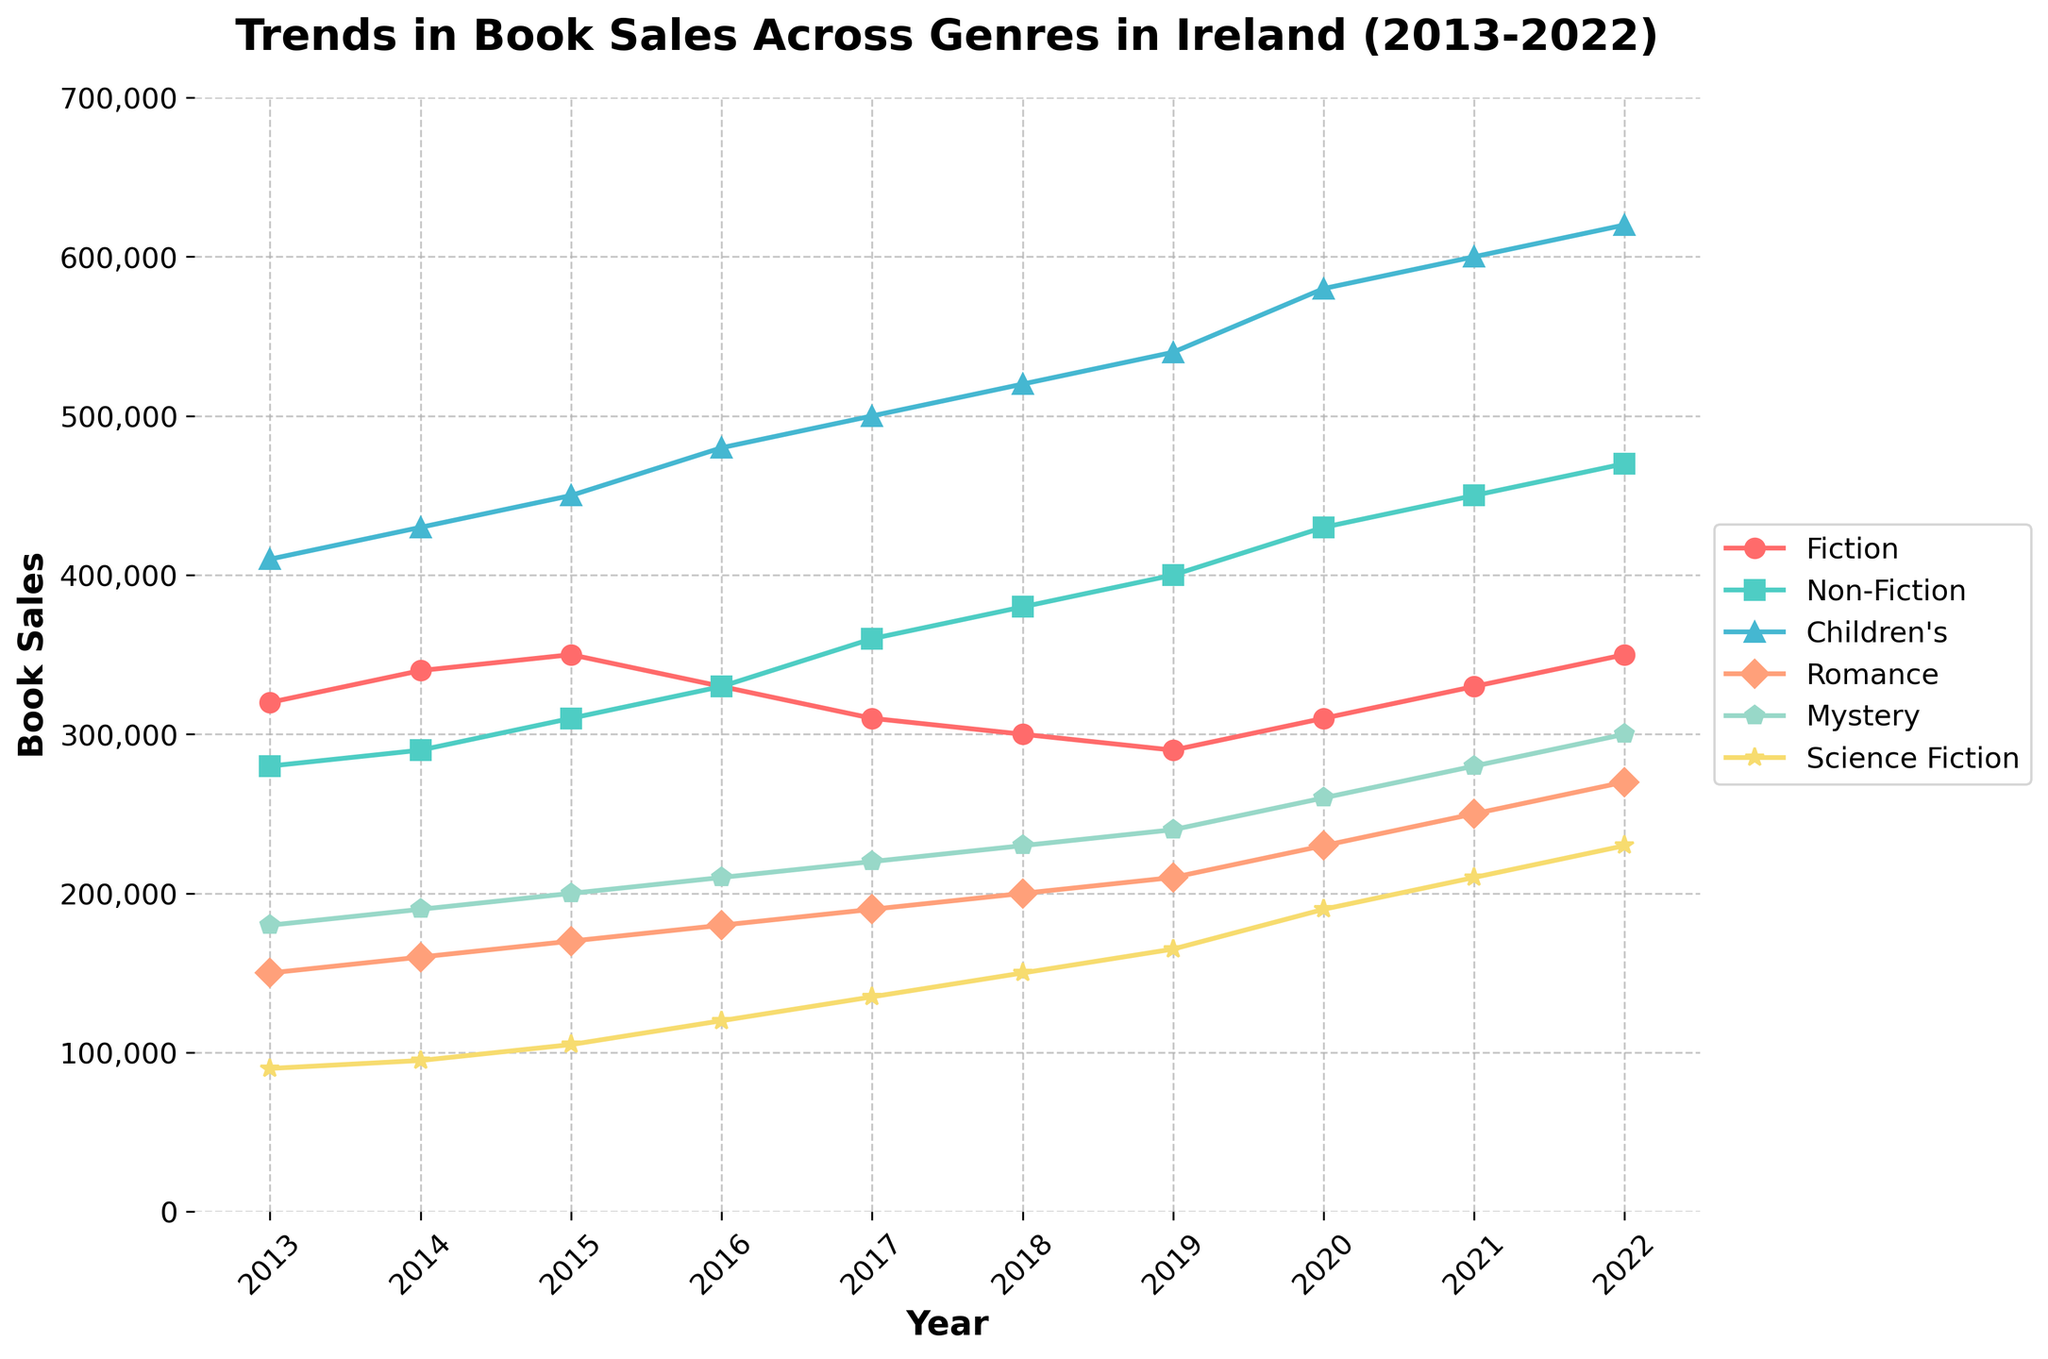Which genre saw the highest increase in sales from 2013 to 2022? To find the genre with the highest increase in sales, we subtract the sales of 2013 from the sales of 2022 for each genre and compare. Children's books increased by 210,000 (620,000 - 410,000), which is the highest increase.
Answer: Children's books How did Fiction sales change from 2017 to 2018 compared to Science Fiction sales in the same period? Fiction sales decreased by 10,000 from 2017 to 2018 (310,000 to 300,000), while Science Fiction sales increased by 15,000 (135,000 to 150,000). This shows Fiction sales decreased, and Science Fiction sales increased during the same period.
Answer: Fiction decreased, Science Fiction increased Which genre had the most consistent growth over the decade? Consistent growth implies steady year-on-year increases. By visually inspecting the lines, we observe that Non-Fiction shows consistent growth without any dips from 2013 to 2022.
Answer: Non-Fiction In which year did Romance sales surpass 200,000? By tracing the Romance sales line on the chart, we see it surpasses 200,000 in 2018.
Answer: 2018 Compare the sales trend of Mystery and Science Fiction throughout the decade. Which genre had a higher final sales figure in 2022? Mystery and Science Fiction both show an upward trend; however, Mystery consistently has higher sales figures throughout the decade. The final sales figure for Mystery in 2022 is 300,000, while for Science Fiction, it is 230,000.
Answer: Mystery What is the average annual sales for Children's books from 2013 to 2022? Adding the Children's books sales from 2013 to 2022: 410,000 + 430,000 + 450,000 + 480,000 + 500,000 + 520,000 + 540,000 + 580,000 + 600,000 + 620,000 = 5,130,000. Dividing by 10, the average annual sales are 513,000.
Answer: 513,000 Did any genre experience a downturn in sales at any point during the decade? By examining the lines, Fiction experienced a downturn from 2015 to 2018, descending from 350,000 to 300,000.
Answer: Fiction Which year saw the highest sales for Mystery books? By examining the Mystery books line, the highest point is in 2022 with sales of 300,000.
Answer: 2022 How do the visual colors help identify different genres? Different colors are used for each genre: Fiction (red), Non-Fiction (turquoise), Children's (blue), Romance (peach), Mystery (mint), and Science Fiction (yellow), enabling easy differentiation.
Answer: Color-coding assists differentiation 